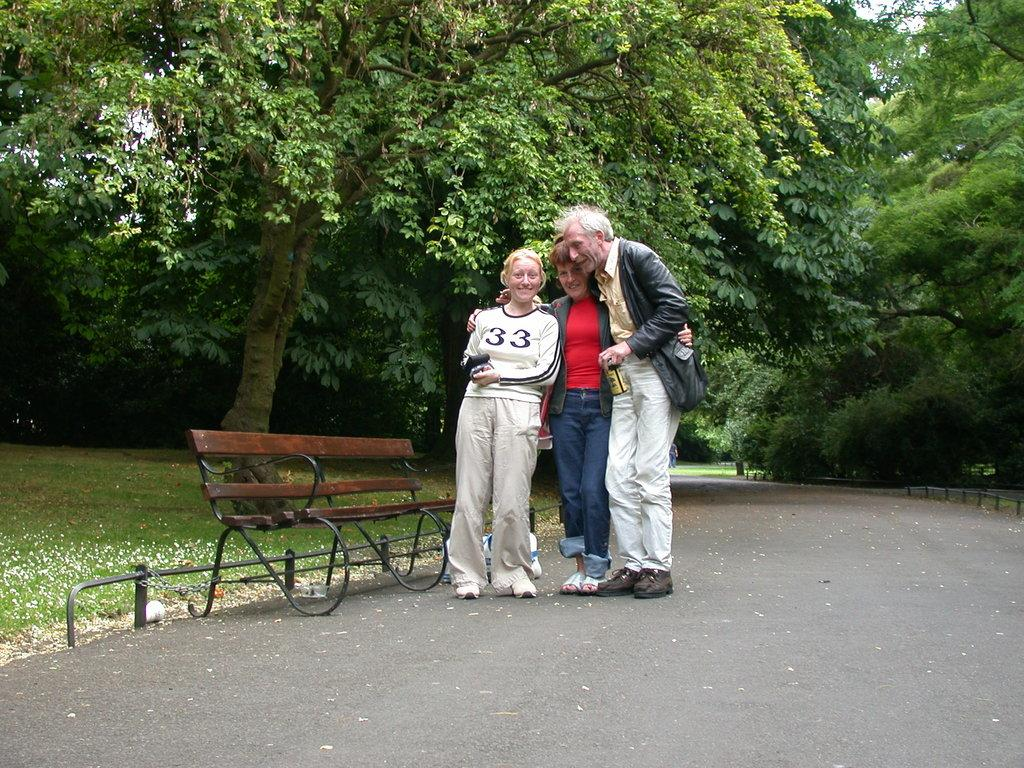How many people are in the image? There are three persons in the image. What are the expressions of the people in the image? Two of the persons are smiling. Where are the persons located in the image? The persons are standing on a path. What other objects can be seen in the image? There is a bench in the image. What type of vegetation is visible in the background of the image? There are trees and grass in the background of the image. What type of blade is being used to cut the crate in the image? There is no blade or crate present in the image. What news headline is being discussed by the persons in the image? There is no indication of a news headline or discussion in the image. 